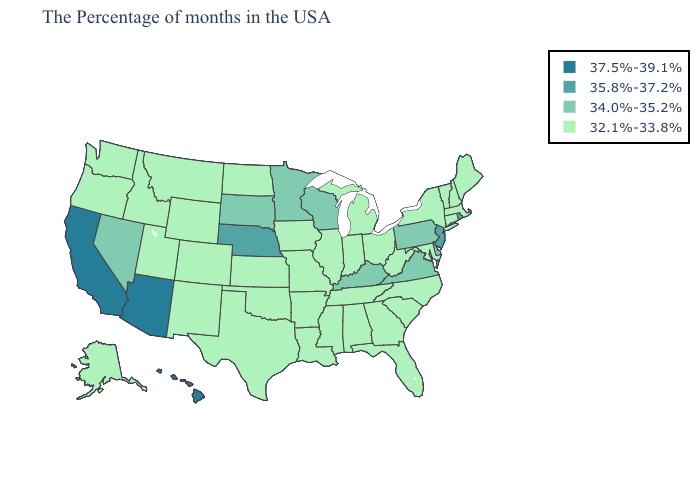Is the legend a continuous bar?
Be succinct. No. Does Massachusetts have the same value as New Jersey?
Quick response, please. No. Does Utah have the highest value in the West?
Answer briefly. No. Which states have the lowest value in the Northeast?
Concise answer only. Maine, Massachusetts, New Hampshire, Vermont, Connecticut, New York. Does Massachusetts have a lower value than Arizona?
Give a very brief answer. Yes. Does Oregon have the highest value in the USA?
Quick response, please. No. Does the first symbol in the legend represent the smallest category?
Answer briefly. No. Among the states that border Missouri , does Nebraska have the lowest value?
Give a very brief answer. No. What is the value of Indiana?
Answer briefly. 32.1%-33.8%. What is the value of Mississippi?
Be succinct. 32.1%-33.8%. What is the lowest value in the USA?
Be succinct. 32.1%-33.8%. Does Texas have the highest value in the South?
Give a very brief answer. No. Which states have the lowest value in the South?
Concise answer only. Maryland, North Carolina, South Carolina, West Virginia, Florida, Georgia, Alabama, Tennessee, Mississippi, Louisiana, Arkansas, Oklahoma, Texas. Does Arizona have the lowest value in the West?
Keep it brief. No. Among the states that border California , does Arizona have the highest value?
Keep it brief. Yes. 